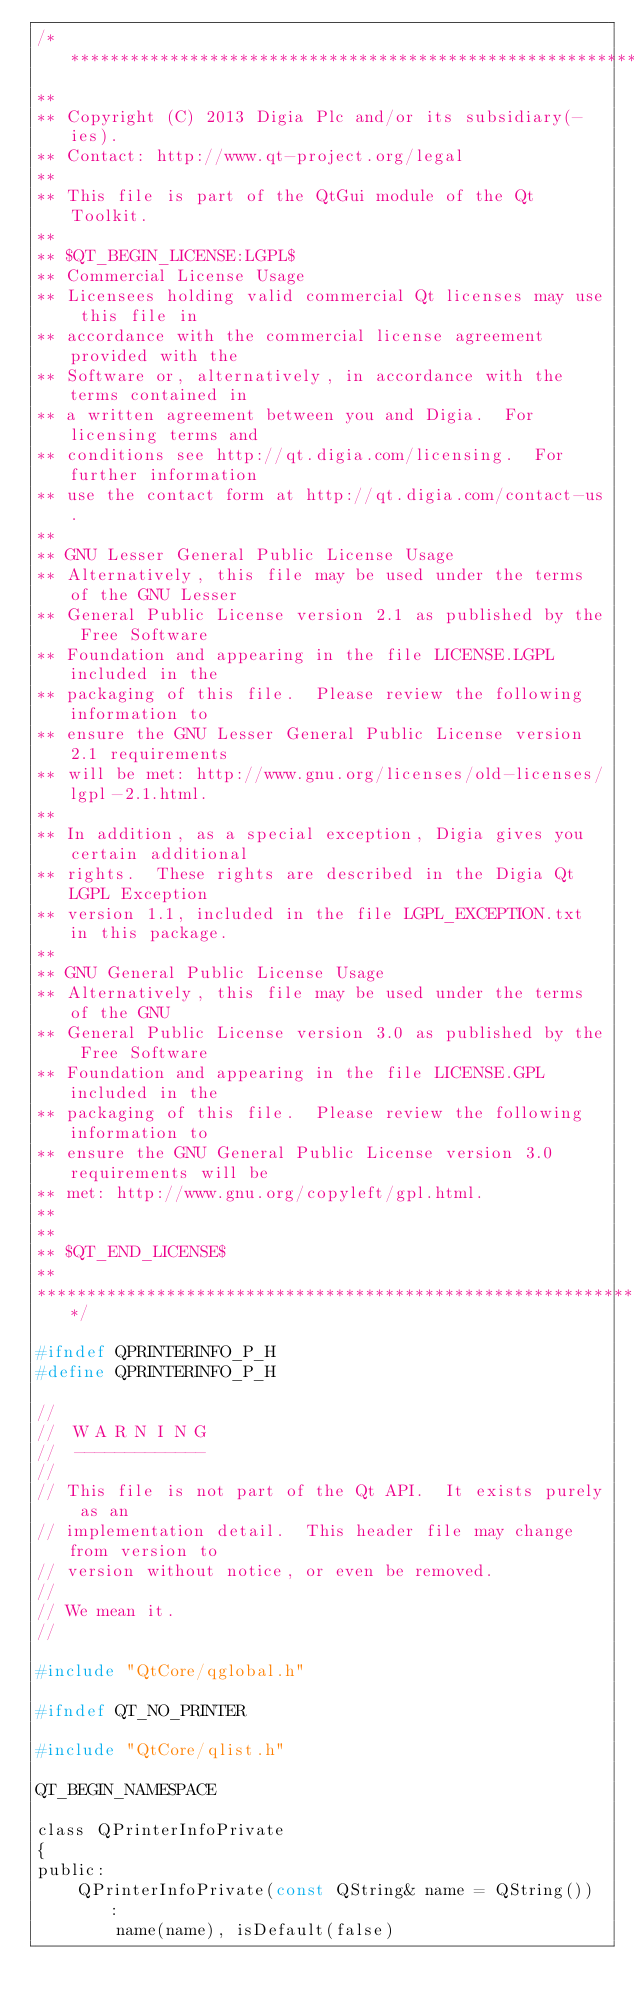Convert code to text. <code><loc_0><loc_0><loc_500><loc_500><_C_>/****************************************************************************
**
** Copyright (C) 2013 Digia Plc and/or its subsidiary(-ies).
** Contact: http://www.qt-project.org/legal
**
** This file is part of the QtGui module of the Qt Toolkit.
**
** $QT_BEGIN_LICENSE:LGPL$
** Commercial License Usage
** Licensees holding valid commercial Qt licenses may use this file in
** accordance with the commercial license agreement provided with the
** Software or, alternatively, in accordance with the terms contained in
** a written agreement between you and Digia.  For licensing terms and
** conditions see http://qt.digia.com/licensing.  For further information
** use the contact form at http://qt.digia.com/contact-us.
**
** GNU Lesser General Public License Usage
** Alternatively, this file may be used under the terms of the GNU Lesser
** General Public License version 2.1 as published by the Free Software
** Foundation and appearing in the file LICENSE.LGPL included in the
** packaging of this file.  Please review the following information to
** ensure the GNU Lesser General Public License version 2.1 requirements
** will be met: http://www.gnu.org/licenses/old-licenses/lgpl-2.1.html.
**
** In addition, as a special exception, Digia gives you certain additional
** rights.  These rights are described in the Digia Qt LGPL Exception
** version 1.1, included in the file LGPL_EXCEPTION.txt in this package.
**
** GNU General Public License Usage
** Alternatively, this file may be used under the terms of the GNU
** General Public License version 3.0 as published by the Free Software
** Foundation and appearing in the file LICENSE.GPL included in the
** packaging of this file.  Please review the following information to
** ensure the GNU General Public License version 3.0 requirements will be
** met: http://www.gnu.org/copyleft/gpl.html.
**
**
** $QT_END_LICENSE$
**
****************************************************************************/

#ifndef QPRINTERINFO_P_H
#define QPRINTERINFO_P_H

//
//  W A R N I N G
//  -------------
//
// This file is not part of the Qt API.  It exists purely as an
// implementation detail.  This header file may change from version to
// version without notice, or even be removed.
//
// We mean it.
//

#include "QtCore/qglobal.h"

#ifndef QT_NO_PRINTER

#include "QtCore/qlist.h"

QT_BEGIN_NAMESPACE

class QPrinterInfoPrivate
{
public:
    QPrinterInfoPrivate(const QString& name = QString()) :
        name(name), isDefault(false)</code> 